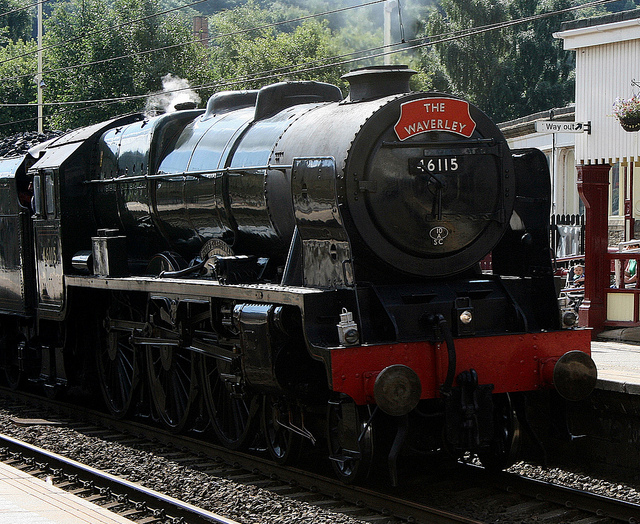Please extract the text content from this image. THE WAVERLEY 46115 Way OUT TO 